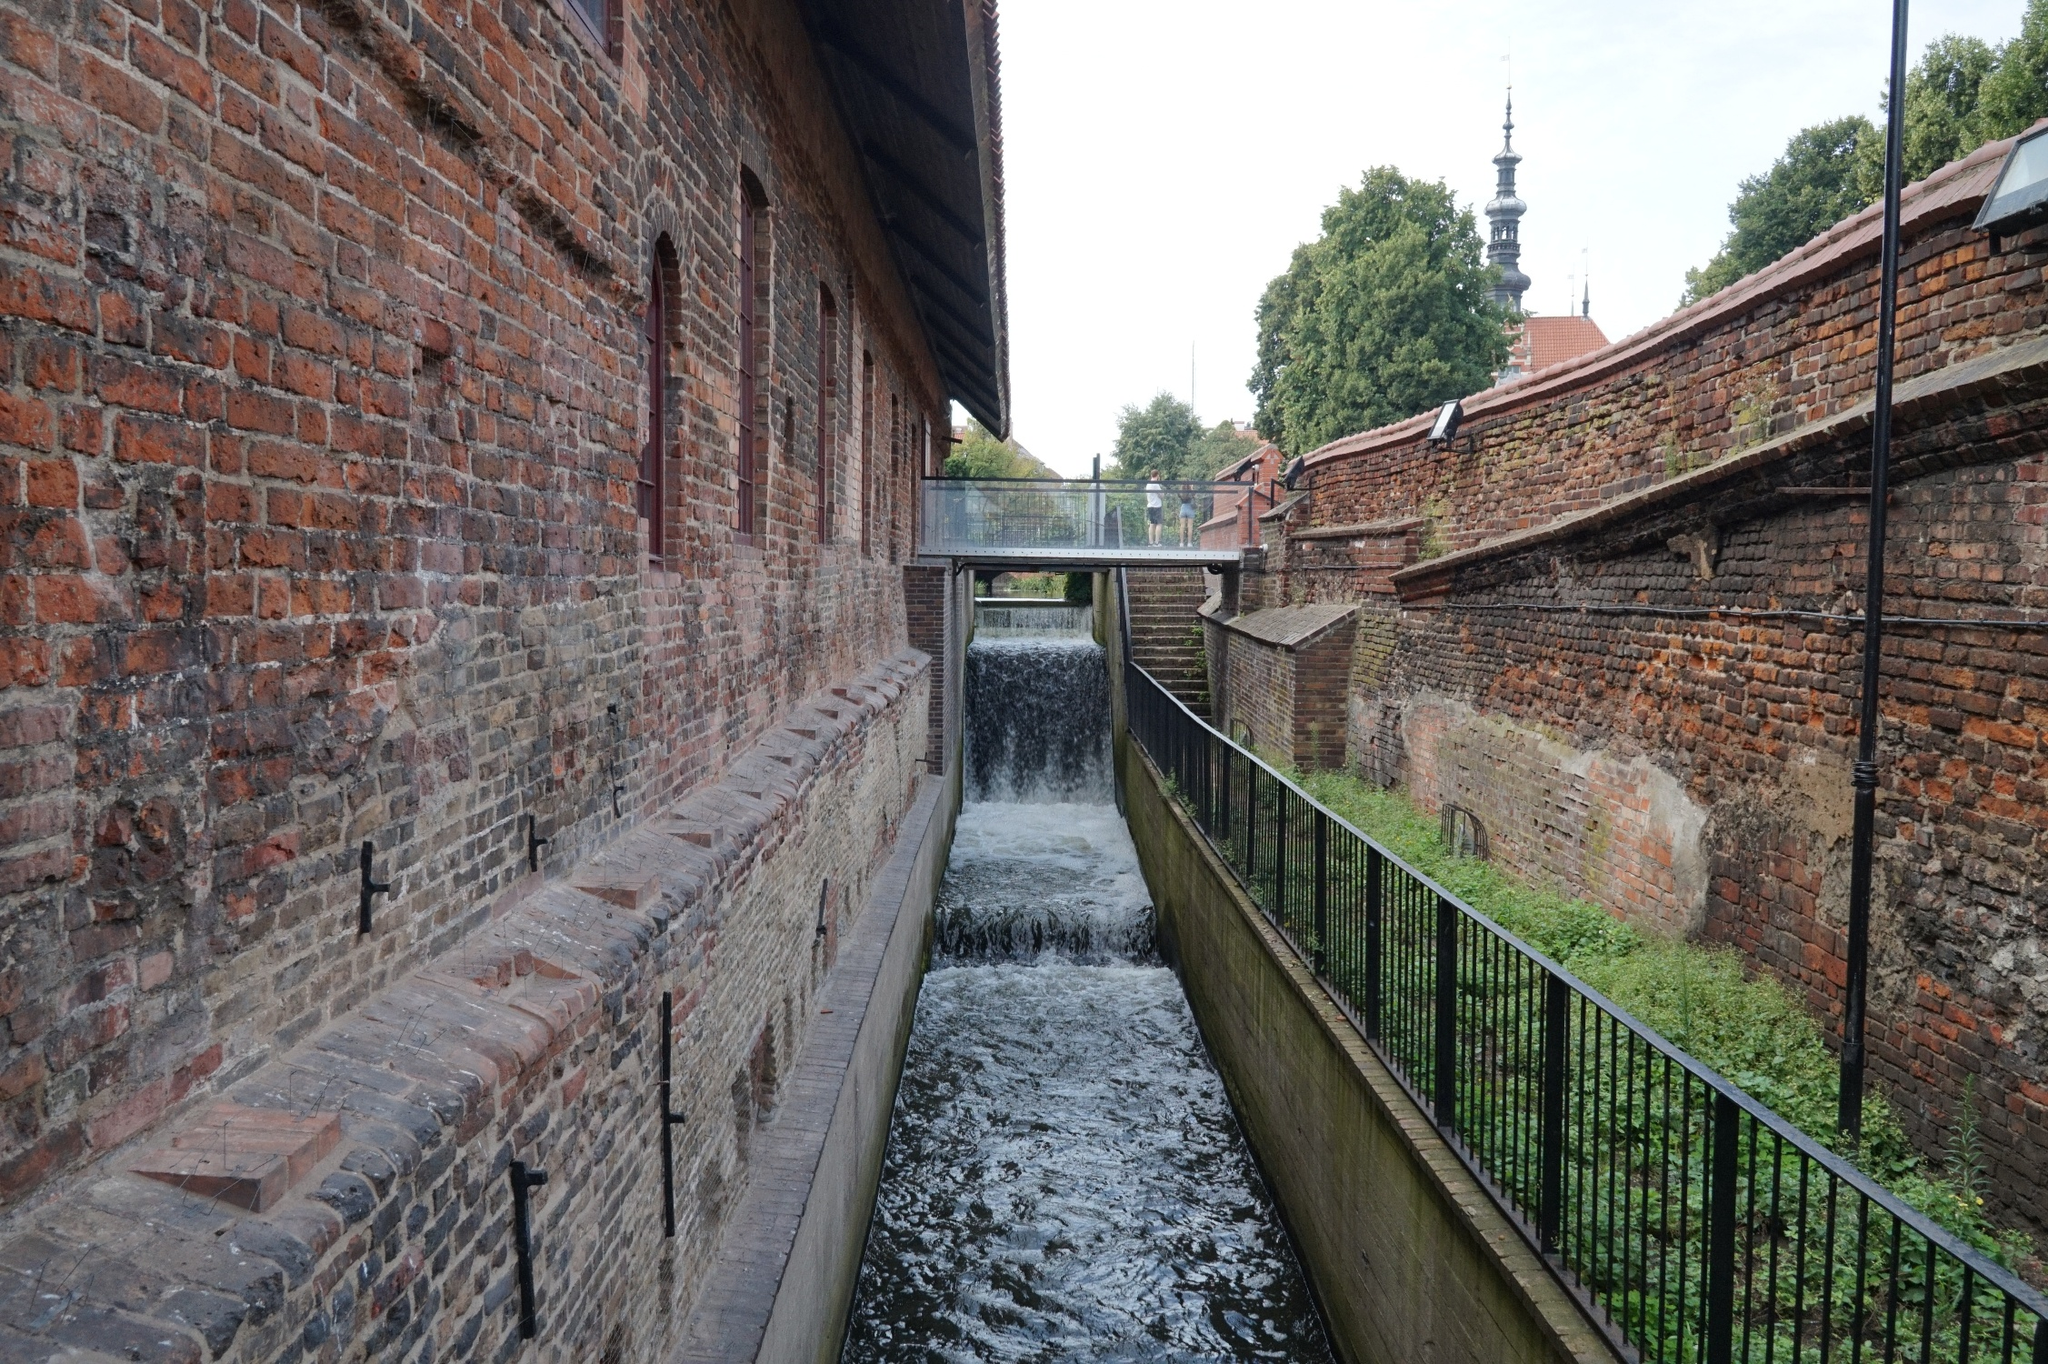Imagine a story that could take place in this setting. In the quiet town of Riverstone, Clara spent her days exploring the historical nooks and crannies of the old canal district. She was particularly drawn to the ancient brick building beside the canal, its arches whispering secrets of the past. One sunny afternoon, as she was sketching the majestic church spire, she noticed a peculiar glint from between the bricks of the canal’s wall. Clara's curiosity led her to discover a hidden trove of antique coins and a weathered journal from a 19th-century treasure hunter. The journal spoke of a grand adventure and a hidden treasure within the town. Clara decided to follow the clues, embarking on a thrilling journey across Riverstone, unraveling its mysteries and uncovering lost histories. 